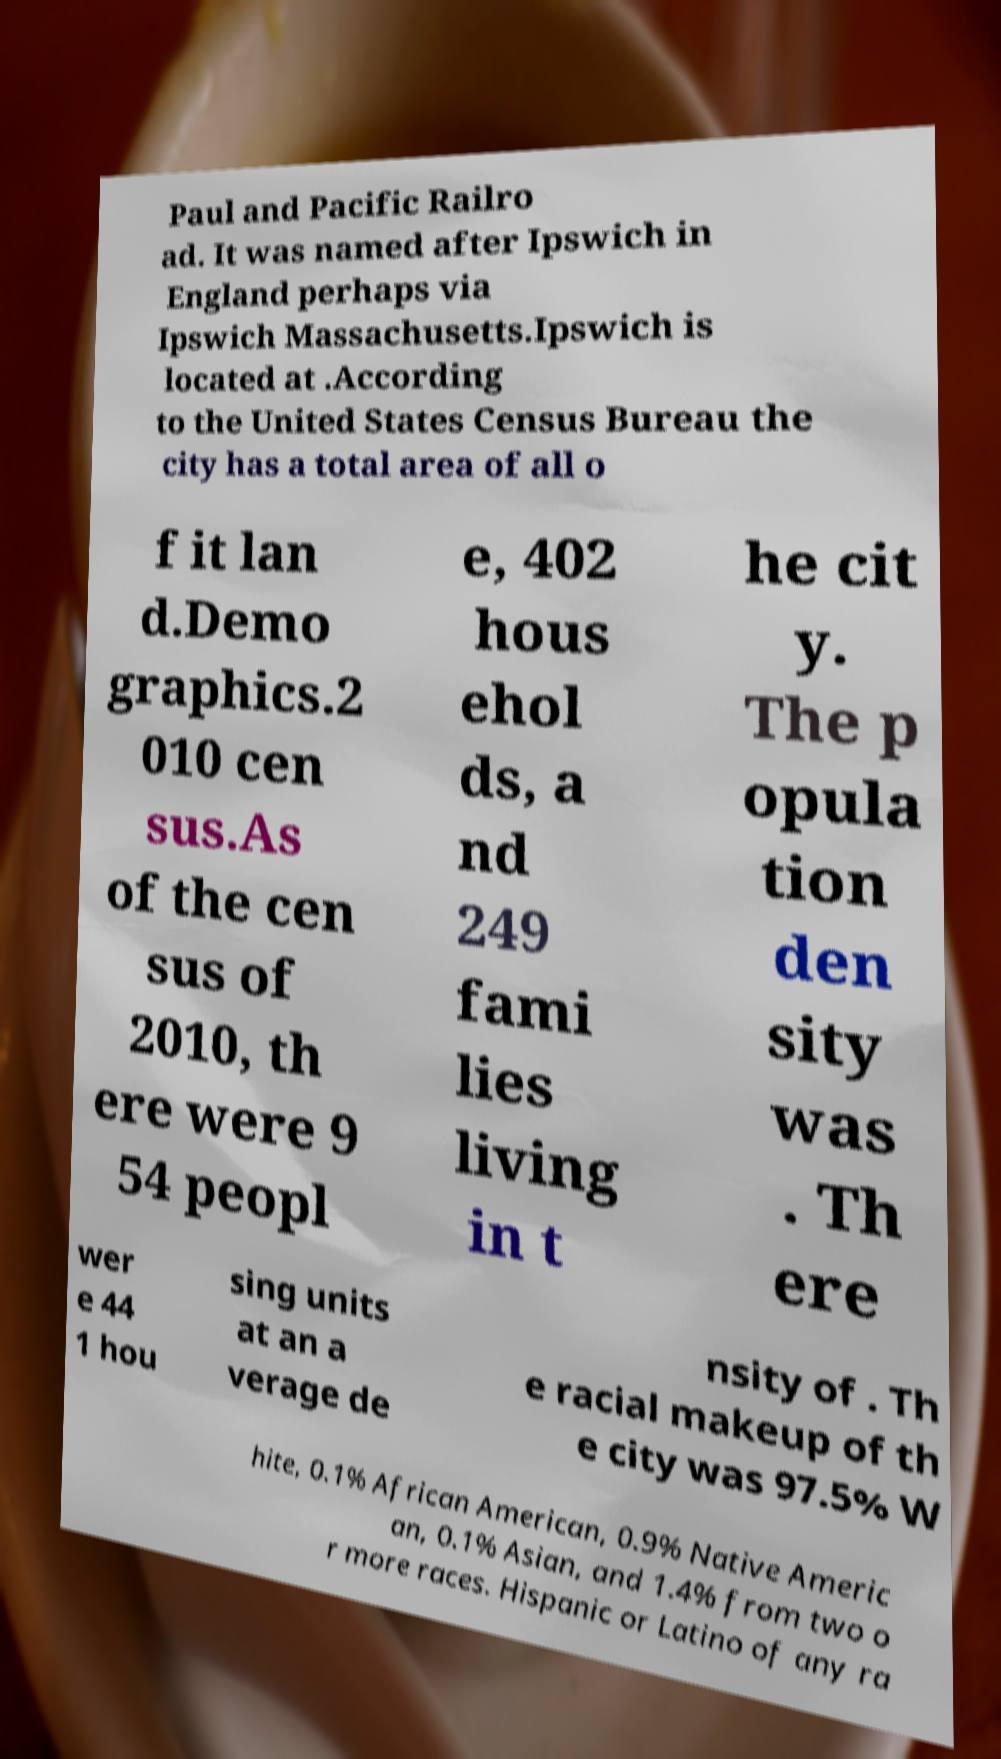Can you accurately transcribe the text from the provided image for me? Paul and Pacific Railro ad. It was named after Ipswich in England perhaps via Ipswich Massachusetts.Ipswich is located at .According to the United States Census Bureau the city has a total area of all o f it lan d.Demo graphics.2 010 cen sus.As of the cen sus of 2010, th ere were 9 54 peopl e, 402 hous ehol ds, a nd 249 fami lies living in t he cit y. The p opula tion den sity was . Th ere wer e 44 1 hou sing units at an a verage de nsity of . Th e racial makeup of th e city was 97.5% W hite, 0.1% African American, 0.9% Native Americ an, 0.1% Asian, and 1.4% from two o r more races. Hispanic or Latino of any ra 